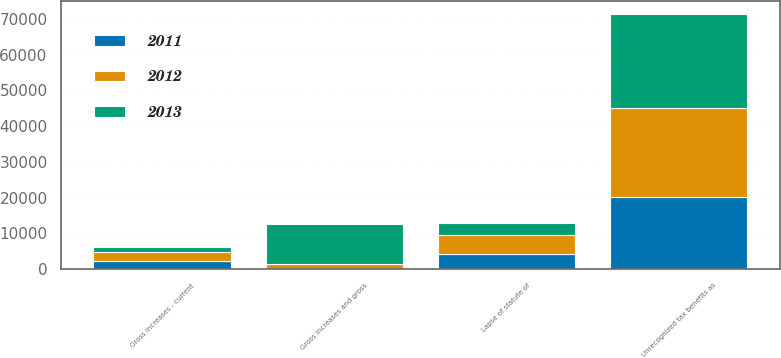Convert chart. <chart><loc_0><loc_0><loc_500><loc_500><stacked_bar_chart><ecel><fcel>Unrecognized tax benefits as<fcel>Gross increases and gross<fcel>Gross increases - current<fcel>Lapse of statute of<nl><fcel>2012<fcel>24771<fcel>1373<fcel>2376<fcel>5359<nl><fcel>2013<fcel>26381<fcel>11268<fcel>1483<fcel>3458<nl><fcel>2011<fcel>20215<fcel>64<fcel>2278<fcel>4108<nl></chart> 